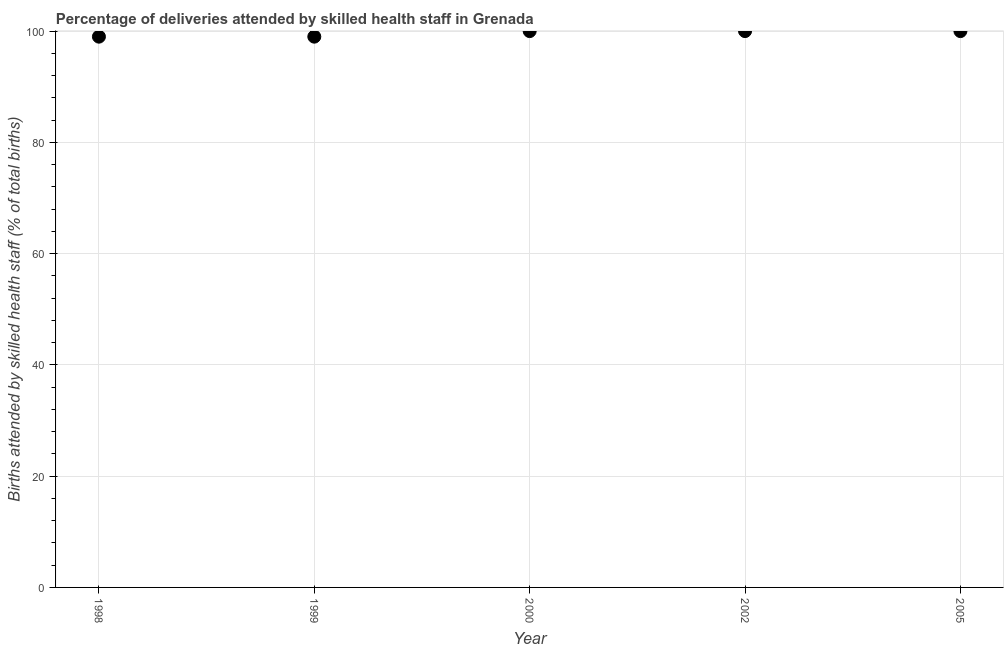What is the sum of the number of births attended by skilled health staff?
Keep it short and to the point. 498. What is the average number of births attended by skilled health staff per year?
Your response must be concise. 99.6. In how many years, is the number of births attended by skilled health staff greater than 56 %?
Provide a short and direct response. 5. What is the ratio of the number of births attended by skilled health staff in 2000 to that in 2002?
Provide a succinct answer. 1. In how many years, is the number of births attended by skilled health staff greater than the average number of births attended by skilled health staff taken over all years?
Make the answer very short. 3. Does the number of births attended by skilled health staff monotonically increase over the years?
Provide a short and direct response. No. How many years are there in the graph?
Make the answer very short. 5. Does the graph contain any zero values?
Provide a short and direct response. No. What is the title of the graph?
Keep it short and to the point. Percentage of deliveries attended by skilled health staff in Grenada. What is the label or title of the X-axis?
Make the answer very short. Year. What is the label or title of the Y-axis?
Offer a terse response. Births attended by skilled health staff (% of total births). What is the Births attended by skilled health staff (% of total births) in 1999?
Give a very brief answer. 99. What is the Births attended by skilled health staff (% of total births) in 2000?
Your answer should be very brief. 100. What is the Births attended by skilled health staff (% of total births) in 2005?
Give a very brief answer. 100. What is the difference between the Births attended by skilled health staff (% of total births) in 1998 and 1999?
Make the answer very short. 0. What is the difference between the Births attended by skilled health staff (% of total births) in 1998 and 2000?
Make the answer very short. -1. What is the difference between the Births attended by skilled health staff (% of total births) in 1998 and 2002?
Make the answer very short. -1. What is the difference between the Births attended by skilled health staff (% of total births) in 1998 and 2005?
Make the answer very short. -1. What is the difference between the Births attended by skilled health staff (% of total births) in 1999 and 2000?
Provide a succinct answer. -1. What is the difference between the Births attended by skilled health staff (% of total births) in 2002 and 2005?
Provide a succinct answer. 0. What is the ratio of the Births attended by skilled health staff (% of total births) in 1998 to that in 1999?
Your answer should be very brief. 1. What is the ratio of the Births attended by skilled health staff (% of total births) in 1998 to that in 2000?
Keep it short and to the point. 0.99. What is the ratio of the Births attended by skilled health staff (% of total births) in 1998 to that in 2005?
Offer a terse response. 0.99. What is the ratio of the Births attended by skilled health staff (% of total births) in 2000 to that in 2002?
Give a very brief answer. 1. What is the ratio of the Births attended by skilled health staff (% of total births) in 2000 to that in 2005?
Offer a terse response. 1. 